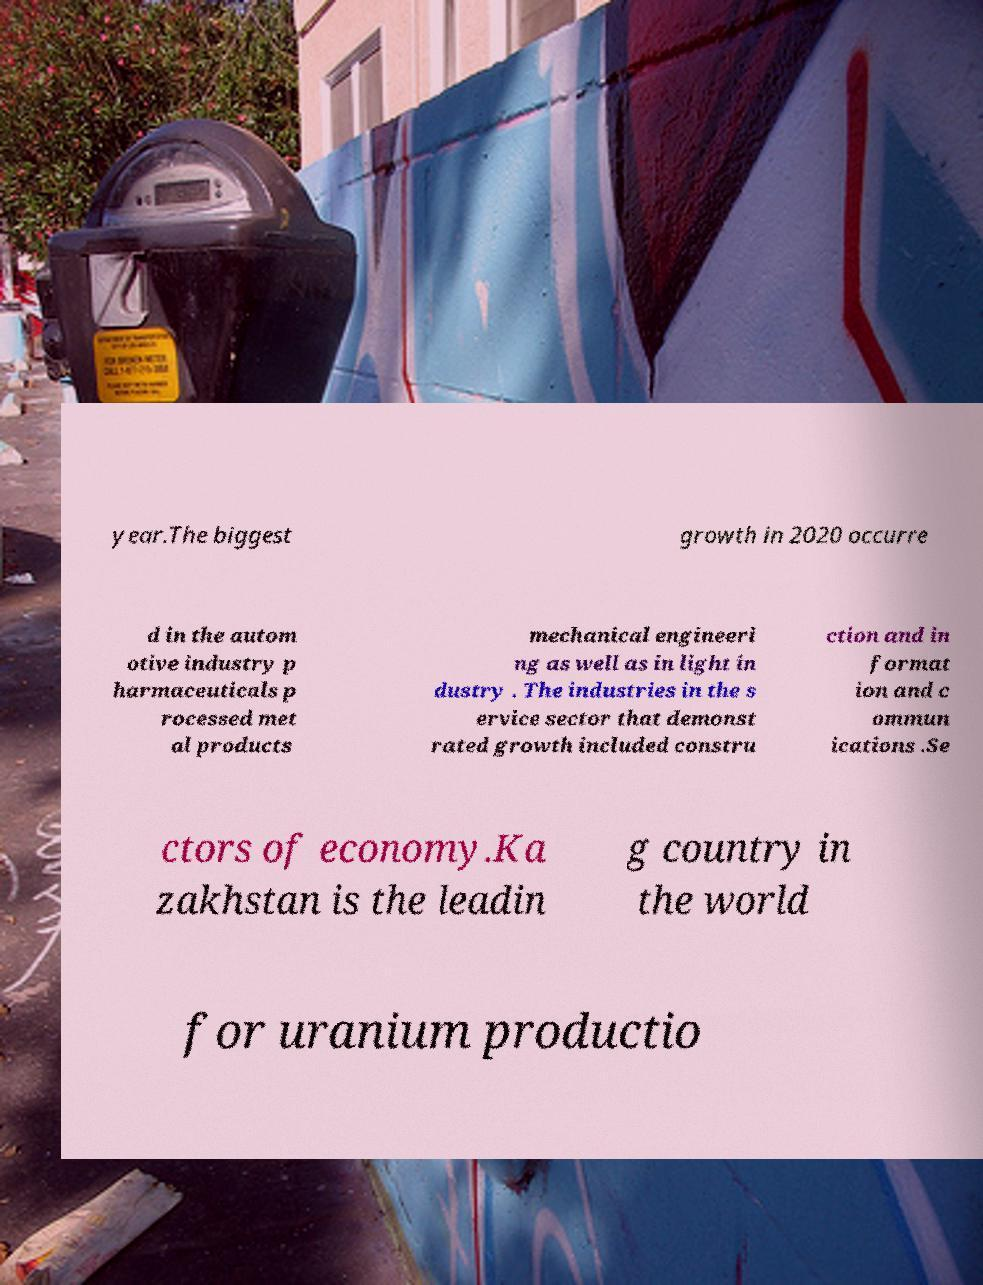Could you assist in decoding the text presented in this image and type it out clearly? year.The biggest growth in 2020 occurre d in the autom otive industry p harmaceuticals p rocessed met al products mechanical engineeri ng as well as in light in dustry . The industries in the s ervice sector that demonst rated growth included constru ction and in format ion and c ommun ications .Se ctors of economy.Ka zakhstan is the leadin g country in the world for uranium productio 